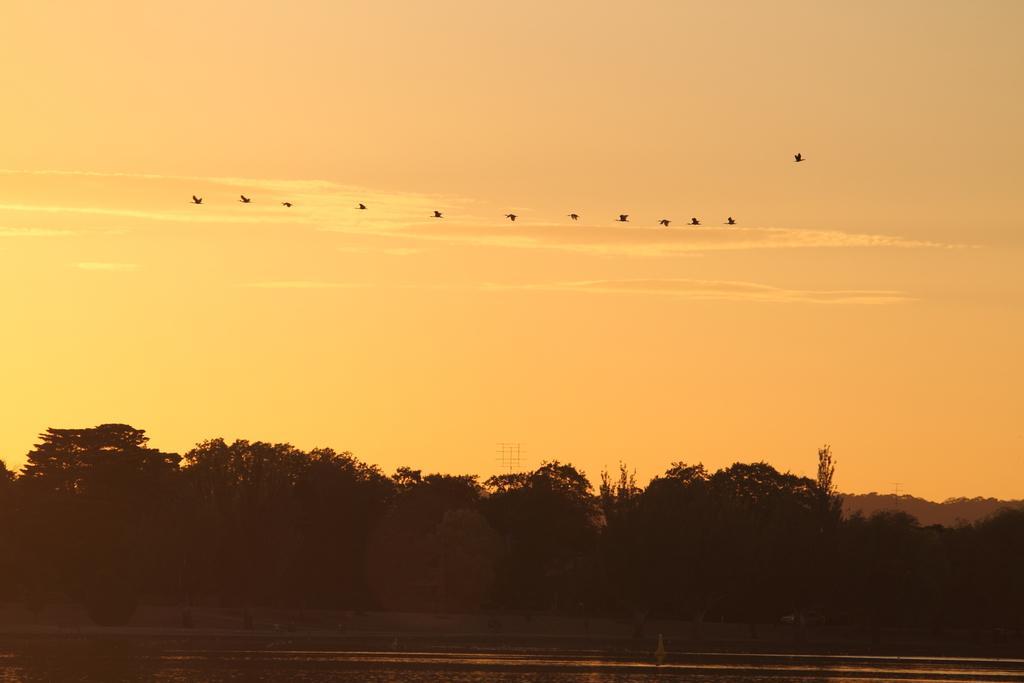How would you summarize this image in a sentence or two? In this image there is a river, trees and a few birds in the sky. 